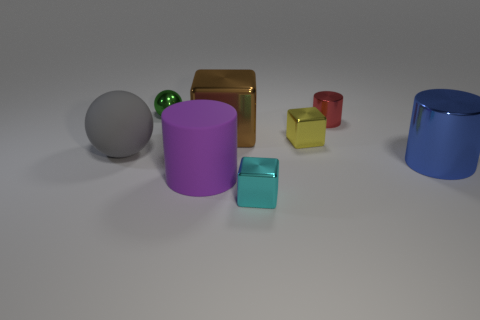What number of other large matte spheres have the same color as the big ball?
Give a very brief answer. 0. What number of other objects are there of the same size as the cyan metallic block?
Keep it short and to the point. 3. There is a thing that is behind the big brown block and left of the small shiny cylinder; what size is it?
Offer a very short reply. Small. What number of other metallic objects have the same shape as the brown metal object?
Make the answer very short. 2. What is the material of the large brown object?
Make the answer very short. Metal. Does the tiny yellow object have the same shape as the large brown metal thing?
Your answer should be very brief. Yes. Is there a red thing that has the same material as the green object?
Your answer should be compact. Yes. What is the color of the large object that is behind the large blue metal cylinder and on the right side of the big matte ball?
Make the answer very short. Brown. What is the small thing that is in front of the large blue cylinder made of?
Your response must be concise. Metal. Is there a green thing that has the same shape as the big purple matte thing?
Ensure brevity in your answer.  No. 